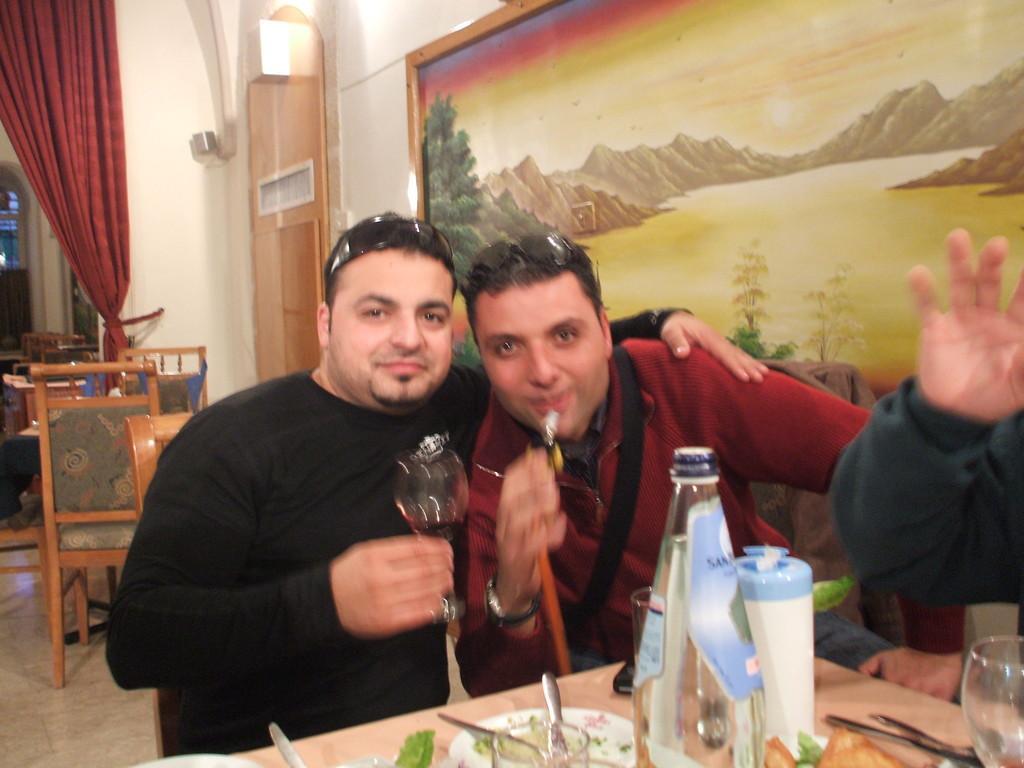Could you give a brief overview of what you see in this image? In this picture there are two guys posing for a picture and in the background we find a painting attached to the wall and then at the top of the table there are food eatables. 